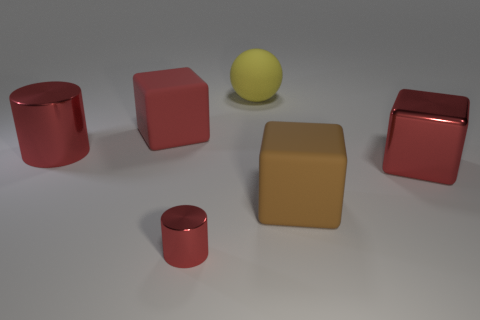There is a metal object that is right of the large yellow object; does it have the same color as the big metallic object that is to the left of the red rubber cube?
Your answer should be very brief. Yes. What number of other objects are there of the same color as the small thing?
Your response must be concise. 3. What is the shape of the large metallic object that is on the right side of the red matte block?
Provide a succinct answer. Cube. Is the number of tiny red matte things less than the number of red metallic objects?
Ensure brevity in your answer.  Yes. Does the red cube in front of the red matte block have the same material as the tiny cylinder?
Your response must be concise. Yes. Is there anything else that is the same size as the red rubber block?
Make the answer very short. Yes. Are there any big yellow matte spheres behind the rubber ball?
Make the answer very short. No. The thing left of the red block on the left side of the red metal thing that is on the right side of the ball is what color?
Provide a succinct answer. Red. What shape is the yellow matte object that is the same size as the red metallic block?
Offer a terse response. Sphere. Is the number of large red metallic spheres greater than the number of big things?
Your answer should be compact. No. 